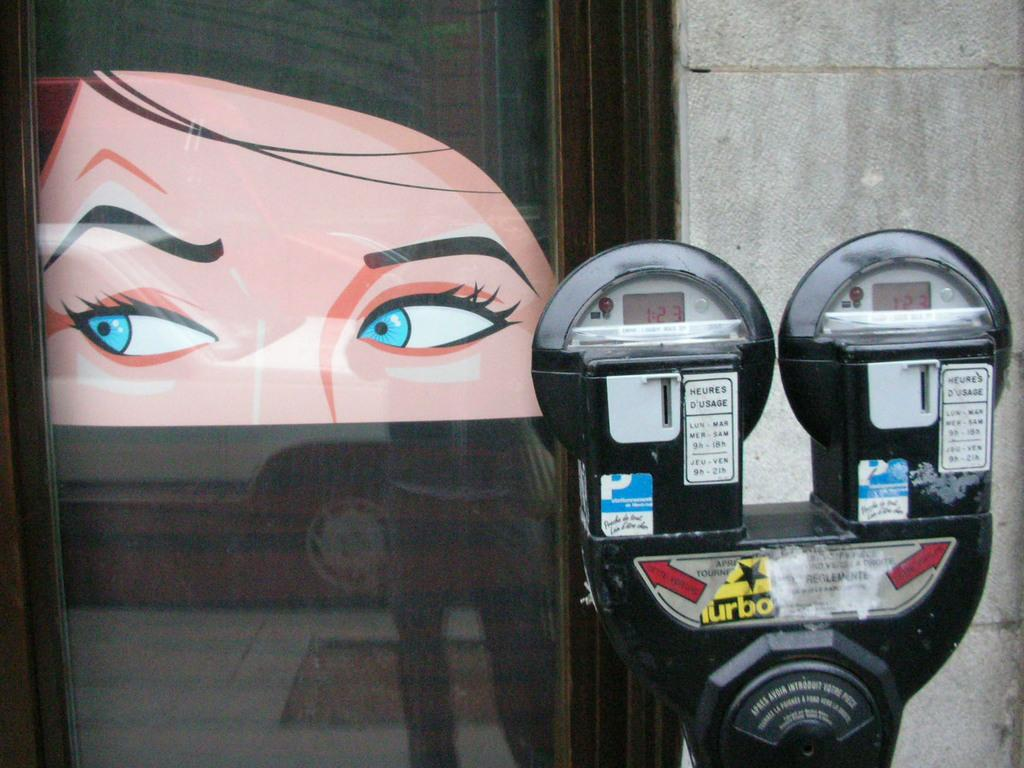<image>
Relay a brief, clear account of the picture shown. The meter has the time "1:23" on the screen. 